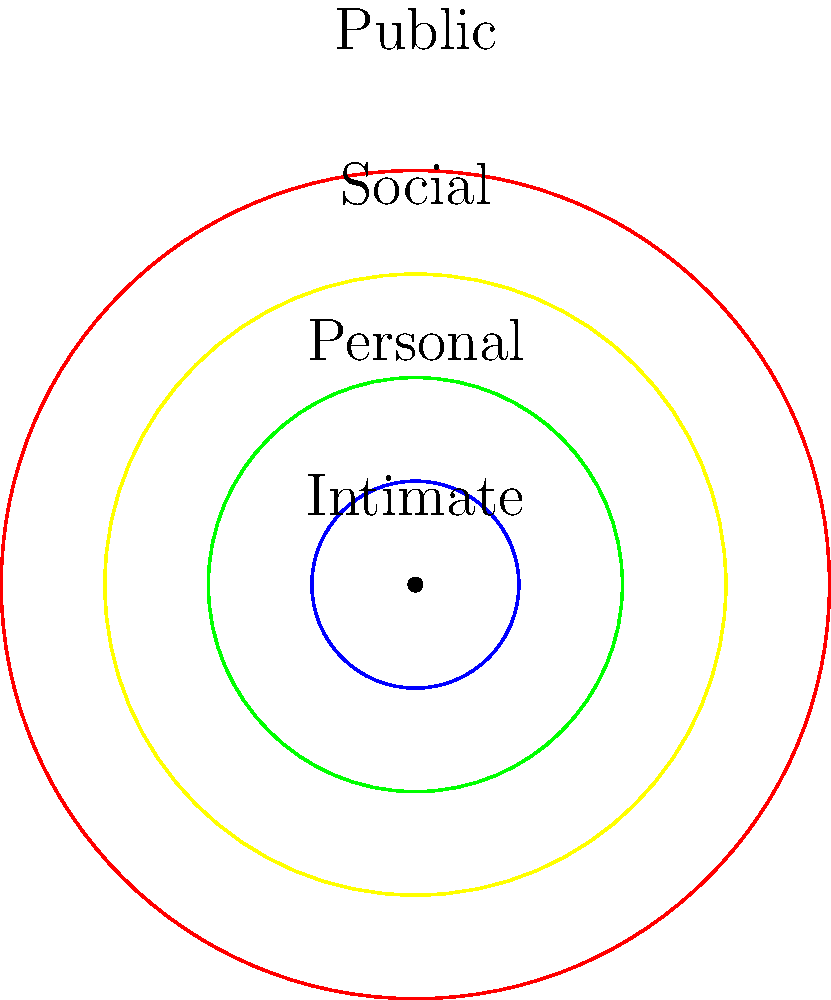In the diagram above, concentric circles represent different personal space zones around an individual. Which zone is most appropriate for effective face-to-face communication in a professional coaching context, and why might this impact the comfort and receptiveness of the client? To answer this question, let's analyze each zone and its implications for professional coaching:

1. Intimate Zone (innermost circle):
   - Distance: 0-18 inches
   - Too close for professional interactions
   - May cause discomfort and anxiety in clients

2. Personal Zone (second circle):
   - Distance: 18 inches - 4 feet
   - Appropriate for one-on-one conversations
   - Allows for personal connection while maintaining professionalism

3. Social Zone (third circle):
   - Distance: 4-12 feet
   - Suitable for casual social interactions
   - May feel too distant for personal coaching

4. Public Zone (outermost circle):
   - Distance: 12+ feet
   - Too far for effective communication
   - Impersonal and may hinder trust-building

For effective face-to-face communication in a professional coaching context, the Personal Zone is most appropriate because:

a) It allows for a balance between intimacy and professionalism
b) It facilitates clear verbal and non-verbal communication
c) It promotes trust and rapport without invading personal space
d) It enables the coach to observe subtle cues in the client's body language

This zone impacts the client's comfort and receptiveness by:
- Creating a safe space for open communication
- Reducing anxiety associated with too much closeness
- Maintaining a professional boundary while allowing connection
- Enhancing the client's ability to focus on the coaching process
Answer: Personal Zone (18 inches - 4 feet) 